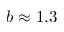<formula> <loc_0><loc_0><loc_500><loc_500>b \approx 1 . 3</formula> 